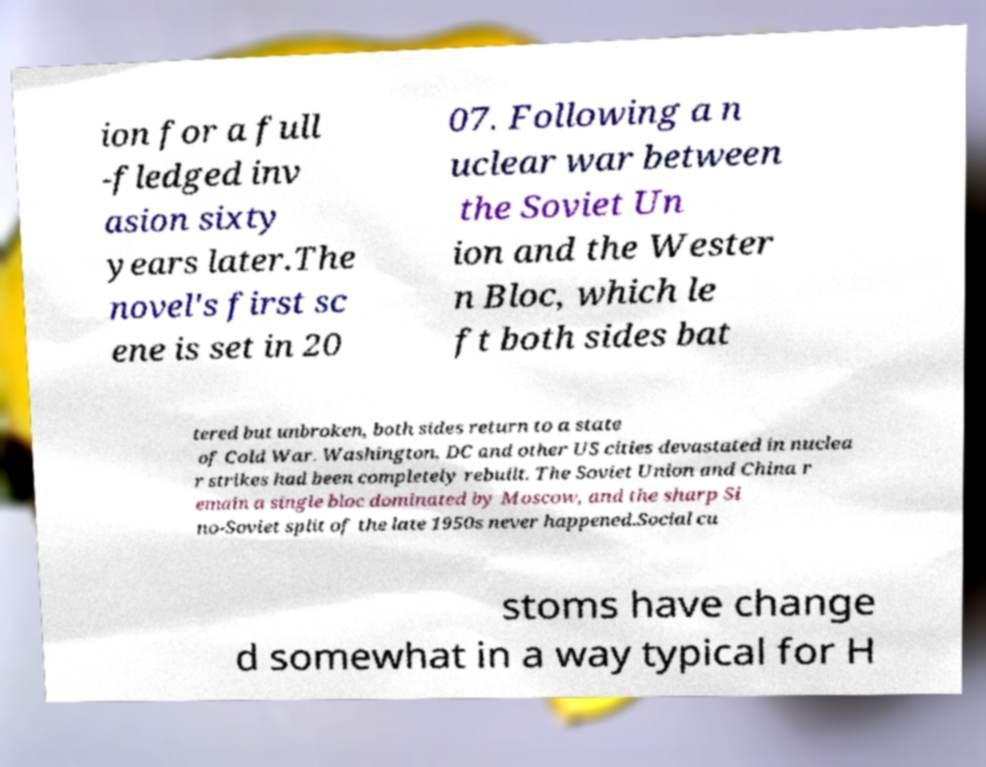Please identify and transcribe the text found in this image. ion for a full -fledged inv asion sixty years later.The novel's first sc ene is set in 20 07. Following a n uclear war between the Soviet Un ion and the Wester n Bloc, which le ft both sides bat tered but unbroken, both sides return to a state of Cold War. Washington, DC and other US cities devastated in nuclea r strikes had been completely rebuilt. The Soviet Union and China r emain a single bloc dominated by Moscow, and the sharp Si no-Soviet split of the late 1950s never happened.Social cu stoms have change d somewhat in a way typical for H 